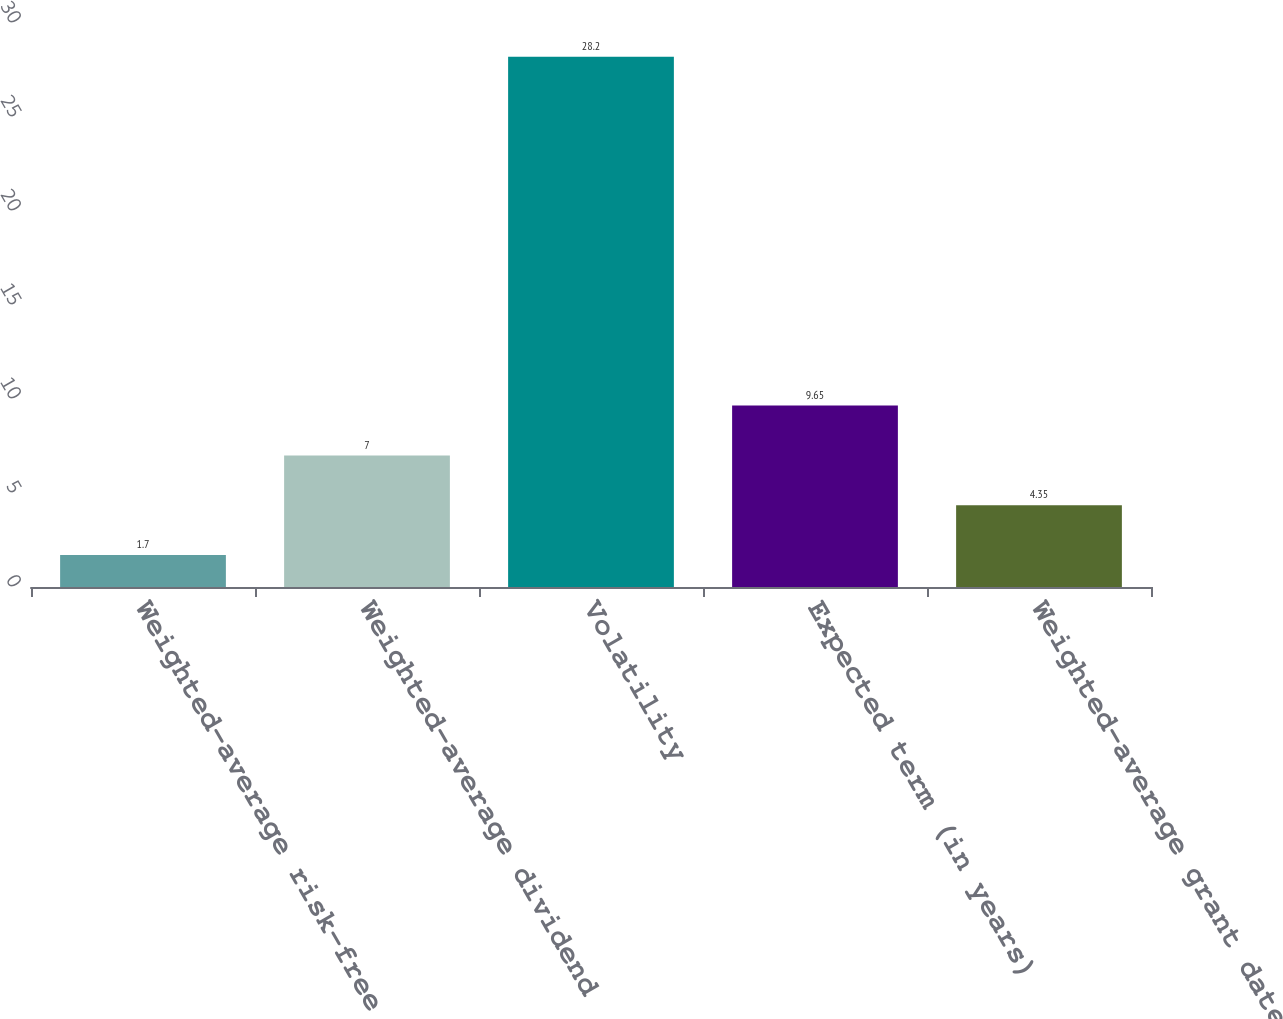<chart> <loc_0><loc_0><loc_500><loc_500><bar_chart><fcel>Weighted-average risk-free<fcel>Weighted-average dividend<fcel>Volatility<fcel>Expected term (in years)<fcel>Weighted-average grant date<nl><fcel>1.7<fcel>7<fcel>28.2<fcel>9.65<fcel>4.35<nl></chart> 